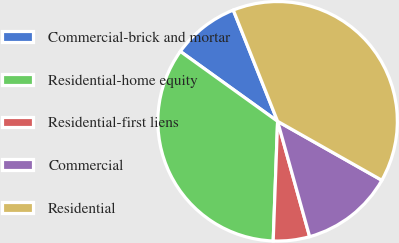Convert chart. <chart><loc_0><loc_0><loc_500><loc_500><pie_chart><fcel>Commercial-brick and mortar<fcel>Residential-home equity<fcel>Residential-first liens<fcel>Commercial<fcel>Residential<nl><fcel>9.05%<fcel>34.33%<fcel>4.9%<fcel>12.49%<fcel>39.23%<nl></chart> 